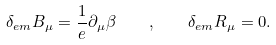<formula> <loc_0><loc_0><loc_500><loc_500>\delta _ { e m } B _ { \mu } = \frac { 1 } { e } \partial _ { \mu } \beta \quad , \quad \delta _ { e m } R _ { \mu } = 0 .</formula> 